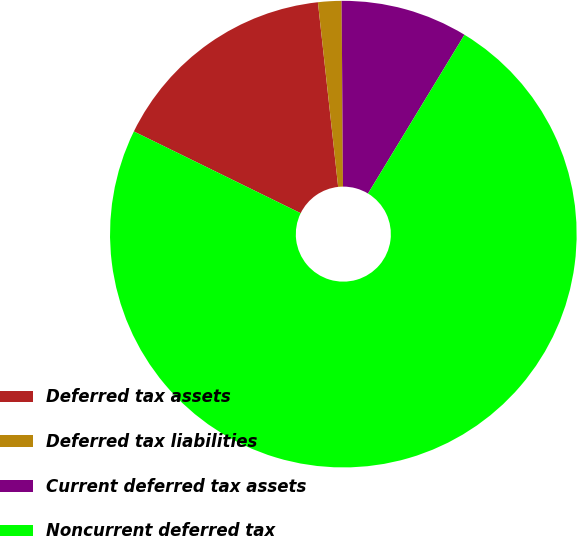<chart> <loc_0><loc_0><loc_500><loc_500><pie_chart><fcel>Deferred tax assets<fcel>Deferred tax liabilities<fcel>Current deferred tax assets<fcel>Noncurrent deferred tax<nl><fcel>16.01%<fcel>1.62%<fcel>8.81%<fcel>73.57%<nl></chart> 